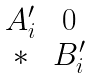Convert formula to latex. <formula><loc_0><loc_0><loc_500><loc_500>\begin{matrix} { A _ { i } ^ { \prime } } & 0 \\ * & { B _ { i } ^ { \prime } } \end{matrix}</formula> 